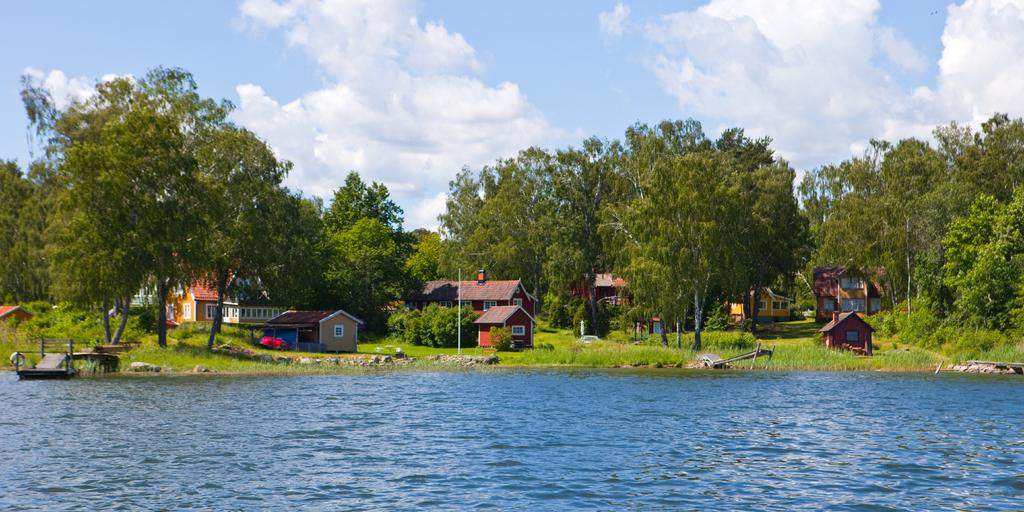What type of natural elements can be seen in the image? There are stones, water, grass, trees, and the sky visible in the image. What man-made structures are present in the image? There are houses with windows and a pole in the image. Are there any objects in the image? Yes, there are some objects in the image. What type of disease is spreading among the trees in the image? There is no indication of any disease among the trees in the image. Can you describe the shape of the spy's hat in the image? There is no spy or hat present in the image. 